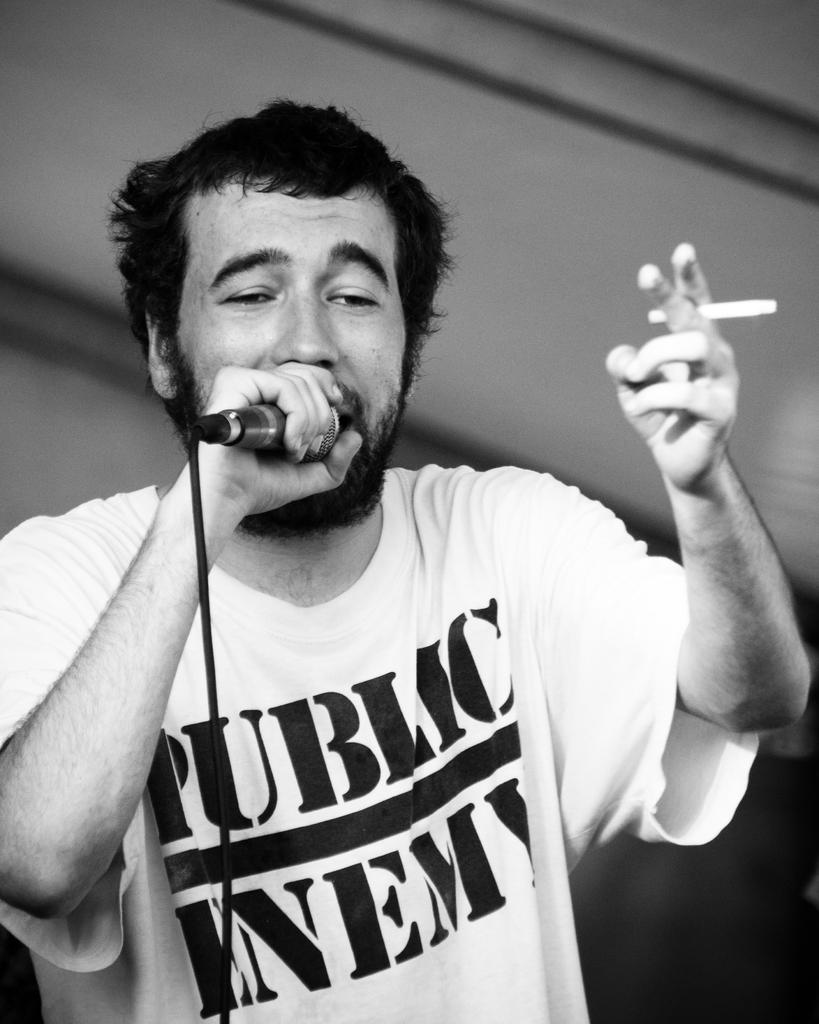What can be seen in the image? There is a person in the image. What is the person holding in his right hand? The person is holding a mic in his right hand. What is the person holding in his left hand? The person is holding a cigar in his left hand. How many oranges are visible in the image? There are no oranges present in the image. Can you hear the person speaking in the image? The image is a still image, so there is no sound or speech to be heard. 